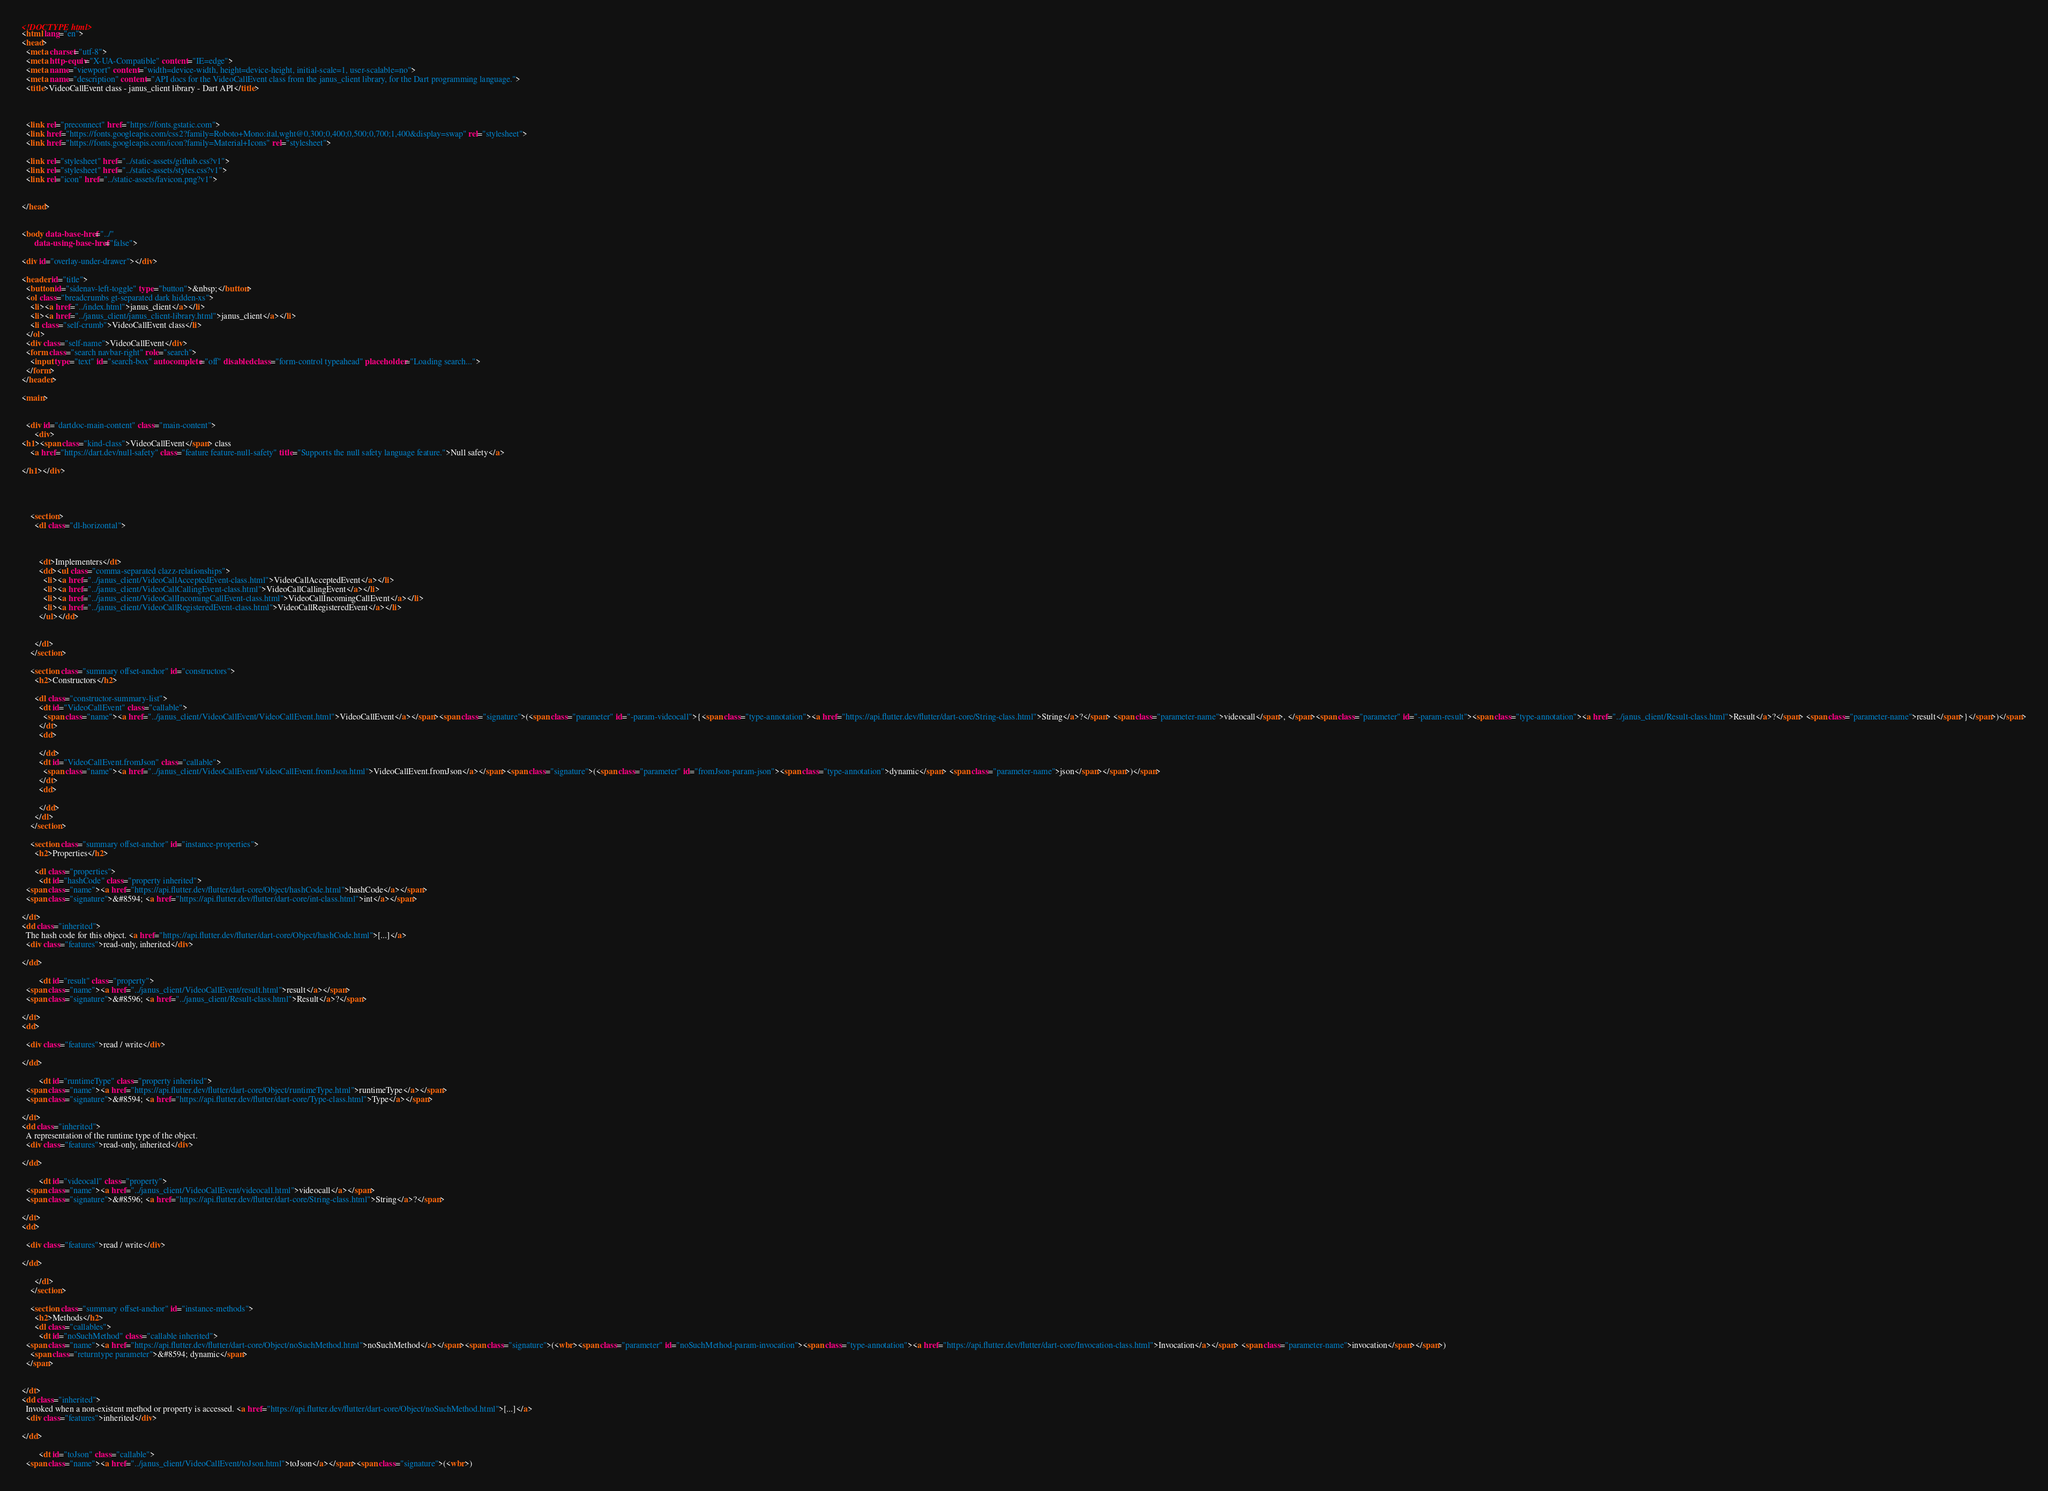Convert code to text. <code><loc_0><loc_0><loc_500><loc_500><_HTML_><!DOCTYPE html>
<html lang="en">
<head>
  <meta charset="utf-8">
  <meta http-equiv="X-UA-Compatible" content="IE=edge">
  <meta name="viewport" content="width=device-width, height=device-height, initial-scale=1, user-scalable=no">
  <meta name="description" content="API docs for the VideoCallEvent class from the janus_client library, for the Dart programming language.">
  <title>VideoCallEvent class - janus_client library - Dart API</title>


  
  <link rel="preconnect" href="https://fonts.gstatic.com">
  <link href="https://fonts.googleapis.com/css2?family=Roboto+Mono:ital,wght@0,300;0,400;0,500;0,700;1,400&display=swap" rel="stylesheet">
  <link href="https://fonts.googleapis.com/icon?family=Material+Icons" rel="stylesheet">
  
  <link rel="stylesheet" href="../static-assets/github.css?v1">
  <link rel="stylesheet" href="../static-assets/styles.css?v1">
  <link rel="icon" href="../static-assets/favicon.png?v1">

  
</head>


<body data-base-href="../"
      data-using-base-href="false">

<div id="overlay-under-drawer"></div>

<header id="title">
  <button id="sidenav-left-toggle" type="button">&nbsp;</button>
  <ol class="breadcrumbs gt-separated dark hidden-xs">
    <li><a href="../index.html">janus_client</a></li>
    <li><a href="../janus_client/janus_client-library.html">janus_client</a></li>
    <li class="self-crumb">VideoCallEvent class</li>
  </ol>
  <div class="self-name">VideoCallEvent</div>
  <form class="search navbar-right" role="search">
    <input type="text" id="search-box" autocomplete="off" disabled class="form-control typeahead" placeholder="Loading search...">
  </form>
</header>

<main>


  <div id="dartdoc-main-content" class="main-content">
      <div>
<h1><span class="kind-class">VideoCallEvent</span> class 
    <a href="https://dart.dev/null-safety" class="feature feature-null-safety" title="Supports the null safety language feature.">Null safety</a>
 
</h1></div>

    


    <section>
      <dl class="dl-horizontal">



        <dt>Implementers</dt>
        <dd><ul class="comma-separated clazz-relationships">
          <li><a href="../janus_client/VideoCallAcceptedEvent-class.html">VideoCallAcceptedEvent</a></li>
          <li><a href="../janus_client/VideoCallCallingEvent-class.html">VideoCallCallingEvent</a></li>
          <li><a href="../janus_client/VideoCallIncomingCallEvent-class.html">VideoCallIncomingCallEvent</a></li>
          <li><a href="../janus_client/VideoCallRegisteredEvent-class.html">VideoCallRegisteredEvent</a></li>
        </ul></dd>


      </dl>
    </section>

    <section class="summary offset-anchor" id="constructors">
      <h2>Constructors</h2>

      <dl class="constructor-summary-list">
        <dt id="VideoCallEvent" class="callable">
          <span class="name"><a href="../janus_client/VideoCallEvent/VideoCallEvent.html">VideoCallEvent</a></span><span class="signature">(<span class="parameter" id="-param-videocall">{<span class="type-annotation"><a href="https://api.flutter.dev/flutter/dart-core/String-class.html">String</a>?</span> <span class="parameter-name">videocall</span>, </span><span class="parameter" id="-param-result"><span class="type-annotation"><a href="../janus_client/Result-class.html">Result</a>?</span> <span class="parameter-name">result</span>}</span>)</span>
        </dt>
        <dd>
           
        </dd>
        <dt id="VideoCallEvent.fromJson" class="callable">
          <span class="name"><a href="../janus_client/VideoCallEvent/VideoCallEvent.fromJson.html">VideoCallEvent.fromJson</a></span><span class="signature">(<span class="parameter" id="fromJson-param-json"><span class="type-annotation">dynamic</span> <span class="parameter-name">json</span></span>)</span>
        </dt>
        <dd>
           
        </dd>
      </dl>
    </section>

    <section class="summary offset-anchor" id="instance-properties">
      <h2>Properties</h2>

      <dl class="properties">
        <dt id="hashCode" class="property inherited">
  <span class="name"><a href="https://api.flutter.dev/flutter/dart-core/Object/hashCode.html">hashCode</a></span>
  <span class="signature">&#8594; <a href="https://api.flutter.dev/flutter/dart-core/int-class.html">int</a></span> 

</dt>
<dd class="inherited">
  The hash code for this object. <a href="https://api.flutter.dev/flutter/dart-core/Object/hashCode.html">[...]</a>
  <div class="features">read-only, inherited</div>

</dd>

        <dt id="result" class="property">
  <span class="name"><a href="../janus_client/VideoCallEvent/result.html">result</a></span>
  <span class="signature">&#8596; <a href="../janus_client/Result-class.html">Result</a>?</span> 

</dt>
<dd>
   
  <div class="features">read / write</div>

</dd>

        <dt id="runtimeType" class="property inherited">
  <span class="name"><a href="https://api.flutter.dev/flutter/dart-core/Object/runtimeType.html">runtimeType</a></span>
  <span class="signature">&#8594; <a href="https://api.flutter.dev/flutter/dart-core/Type-class.html">Type</a></span> 

</dt>
<dd class="inherited">
  A representation of the runtime type of the object. 
  <div class="features">read-only, inherited</div>

</dd>

        <dt id="videocall" class="property">
  <span class="name"><a href="../janus_client/VideoCallEvent/videocall.html">videocall</a></span>
  <span class="signature">&#8596; <a href="https://api.flutter.dev/flutter/dart-core/String-class.html">String</a>?</span> 

</dt>
<dd>
   
  <div class="features">read / write</div>

</dd>

      </dl>
    </section>

    <section class="summary offset-anchor" id="instance-methods">
      <h2>Methods</h2>
      <dl class="callables">
        <dt id="noSuchMethod" class="callable inherited">
  <span class="name"><a href="https://api.flutter.dev/flutter/dart-core/Object/noSuchMethod.html">noSuchMethod</a></span><span class="signature">(<wbr><span class="parameter" id="noSuchMethod-param-invocation"><span class="type-annotation"><a href="https://api.flutter.dev/flutter/dart-core/Invocation-class.html">Invocation</a></span> <span class="parameter-name">invocation</span></span>)
    <span class="returntype parameter">&#8594; dynamic</span>
  </span>
  

</dt>
<dd class="inherited">
  Invoked when a non-existent method or property is accessed. <a href="https://api.flutter.dev/flutter/dart-core/Object/noSuchMethod.html">[...]</a>
  <div class="features">inherited</div>

</dd>

        <dt id="toJson" class="callable">
  <span class="name"><a href="../janus_client/VideoCallEvent/toJson.html">toJson</a></span><span class="signature">(<wbr>)</code> 